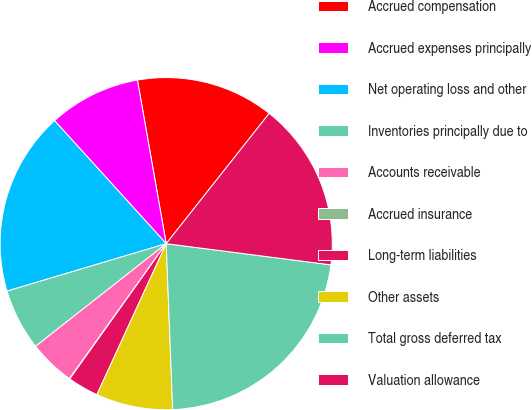<chart> <loc_0><loc_0><loc_500><loc_500><pie_chart><fcel>Accrued compensation<fcel>Accrued expenses principally<fcel>Net operating loss and other<fcel>Inventories principally due to<fcel>Accounts receivable<fcel>Accrued insurance<fcel>Long-term liabilities<fcel>Other assets<fcel>Total gross deferred tax<fcel>Valuation allowance<nl><fcel>13.42%<fcel>8.96%<fcel>17.88%<fcel>5.99%<fcel>4.5%<fcel>0.04%<fcel>3.01%<fcel>7.47%<fcel>22.34%<fcel>16.39%<nl></chart> 